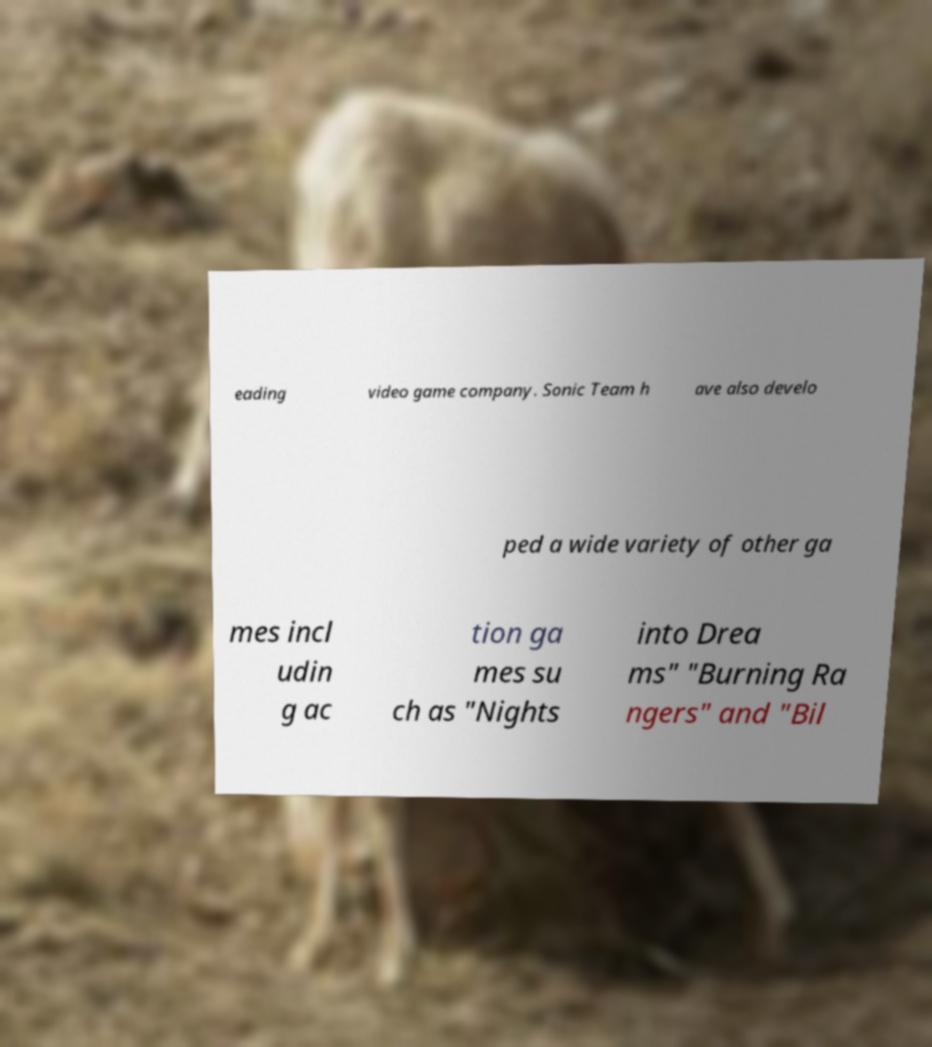Please identify and transcribe the text found in this image. eading video game company. Sonic Team h ave also develo ped a wide variety of other ga mes incl udin g ac tion ga mes su ch as "Nights into Drea ms" "Burning Ra ngers" and "Bil 